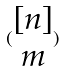<formula> <loc_0><loc_0><loc_500><loc_500>( \begin{matrix} [ n ] \\ m \end{matrix} )</formula> 